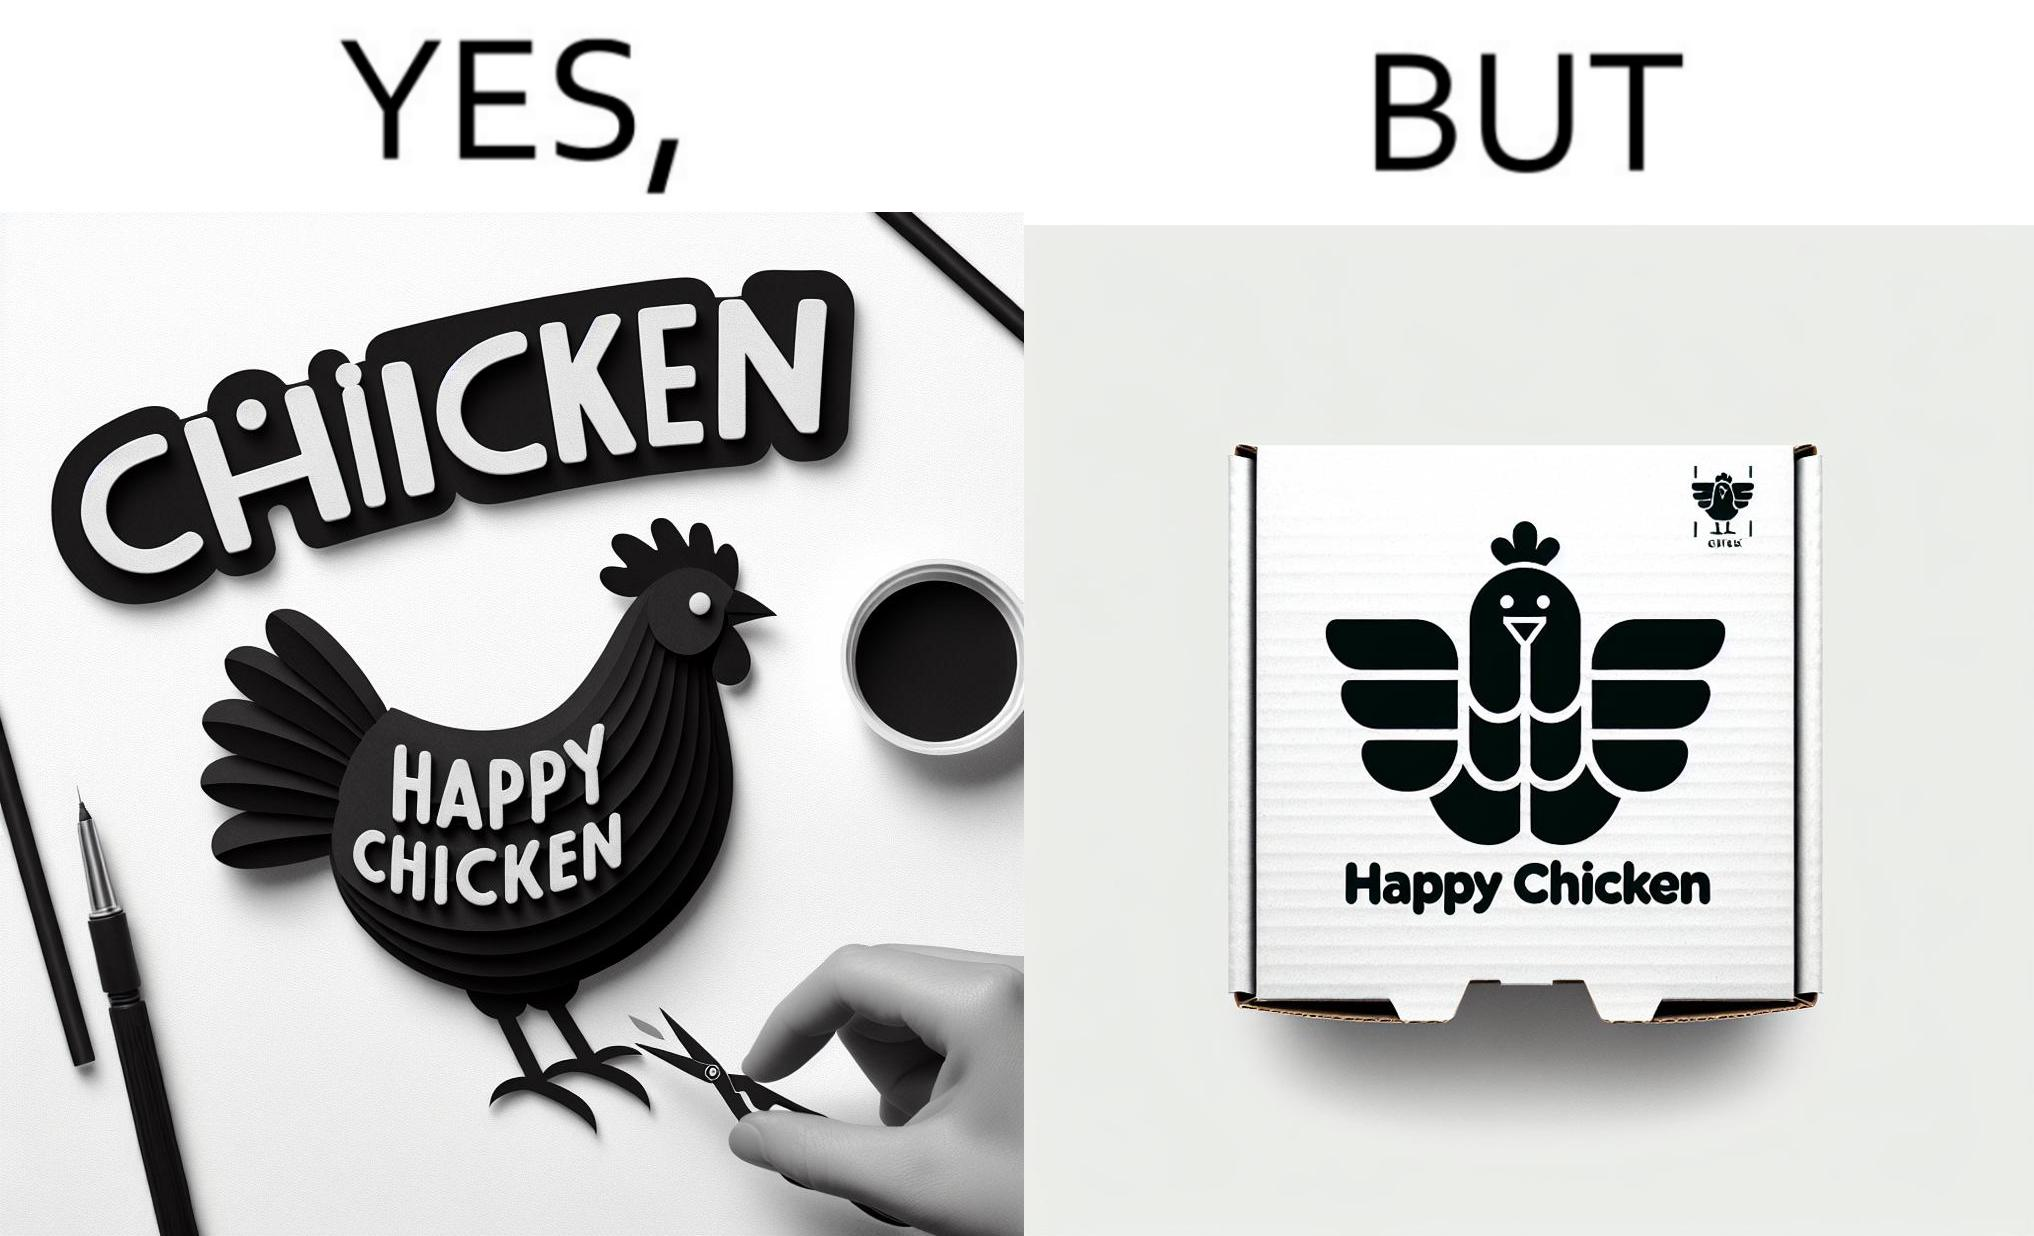Describe the contrast between the left and right parts of this image. In the left part of the image: a chicken with a quote "HAPPY CHICKEN" in the background In the right part of the image: chicken pieces packed in boxes with a logo of a chicken with name "HAPPY CHICKEN" printed on it 